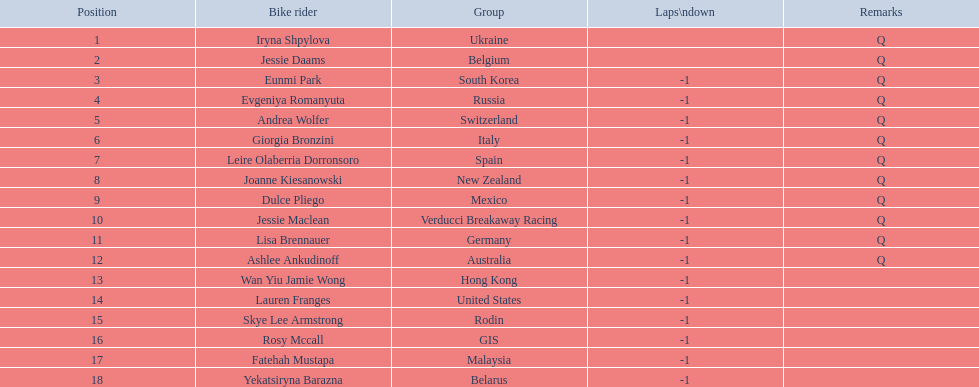Who competed in the race? Iryna Shpylova, Jessie Daams, Eunmi Park, Evgeniya Romanyuta, Andrea Wolfer, Giorgia Bronzini, Leire Olaberria Dorronsoro, Joanne Kiesanowski, Dulce Pliego, Jessie Maclean, Lisa Brennauer, Ashlee Ankudinoff, Wan Yiu Jamie Wong, Lauren Franges, Skye Lee Armstrong, Rosy Mccall, Fatehah Mustapa, Yekatsiryna Barazna. Who ranked highest in the race? Iryna Shpylova. 